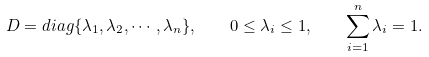Convert formula to latex. <formula><loc_0><loc_0><loc_500><loc_500>D = d i a g \{ \lambda _ { 1 } , \lambda _ { 2 } , \cdots , \lambda _ { n } \} , \quad 0 \leq \lambda _ { i } \leq 1 , \quad \sum _ { i = 1 } ^ { n } \lambda _ { i } = 1 .</formula> 